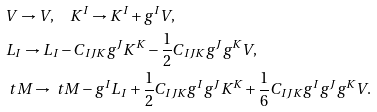<formula> <loc_0><loc_0><loc_500><loc_500>& V \rightarrow V , \quad K ^ { I } \rightarrow K ^ { I } + g ^ { I } V , \\ & L _ { I } \rightarrow L _ { I } - C _ { I J K } g ^ { J } K ^ { K } - \frac { 1 } { 2 } C _ { I J K } g ^ { J } g ^ { K } V , \\ & \ t M \rightarrow \ t M - g ^ { I } L _ { I } + \frac { 1 } { 2 } C _ { I J K } g ^ { I } g ^ { J } K ^ { K } + \frac { 1 } { 6 } C _ { I J K } g ^ { I } g ^ { J } g ^ { K } V .</formula> 